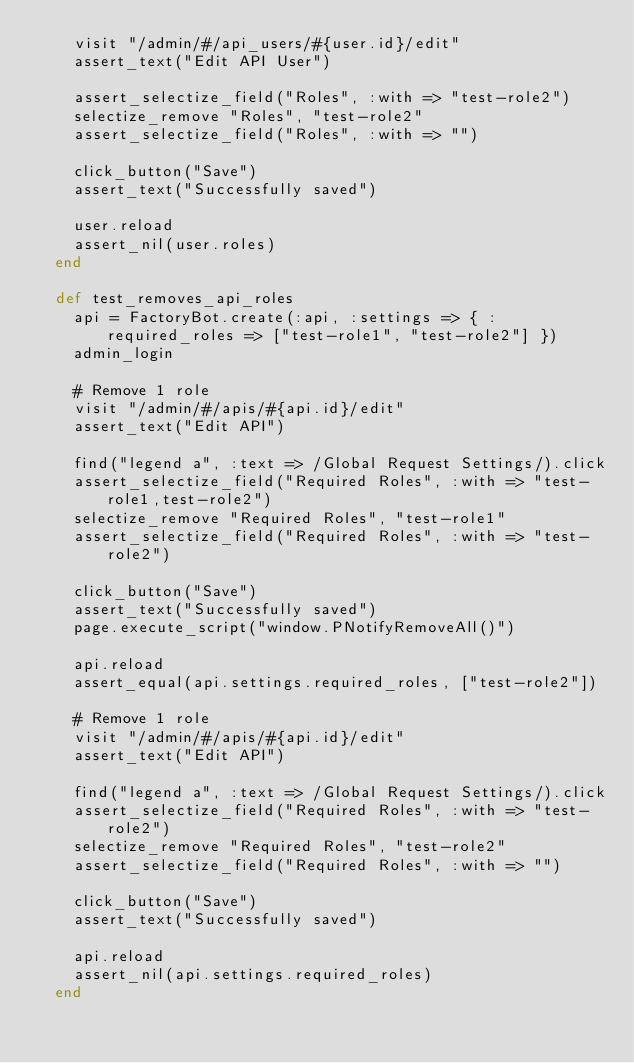<code> <loc_0><loc_0><loc_500><loc_500><_Ruby_>    visit "/admin/#/api_users/#{user.id}/edit"
    assert_text("Edit API User")

    assert_selectize_field("Roles", :with => "test-role2")
    selectize_remove "Roles", "test-role2"
    assert_selectize_field("Roles", :with => "")

    click_button("Save")
    assert_text("Successfully saved")

    user.reload
    assert_nil(user.roles)
  end

  def test_removes_api_roles
    api = FactoryBot.create(:api, :settings => { :required_roles => ["test-role1", "test-role2"] })
    admin_login

    # Remove 1 role
    visit "/admin/#/apis/#{api.id}/edit"
    assert_text("Edit API")

    find("legend a", :text => /Global Request Settings/).click
    assert_selectize_field("Required Roles", :with => "test-role1,test-role2")
    selectize_remove "Required Roles", "test-role1"
    assert_selectize_field("Required Roles", :with => "test-role2")

    click_button("Save")
    assert_text("Successfully saved")
    page.execute_script("window.PNotifyRemoveAll()")

    api.reload
    assert_equal(api.settings.required_roles, ["test-role2"])

    # Remove 1 role
    visit "/admin/#/apis/#{api.id}/edit"
    assert_text("Edit API")

    find("legend a", :text => /Global Request Settings/).click
    assert_selectize_field("Required Roles", :with => "test-role2")
    selectize_remove "Required Roles", "test-role2"
    assert_selectize_field("Required Roles", :with => "")

    click_button("Save")
    assert_text("Successfully saved")

    api.reload
    assert_nil(api.settings.required_roles)
  end</code> 